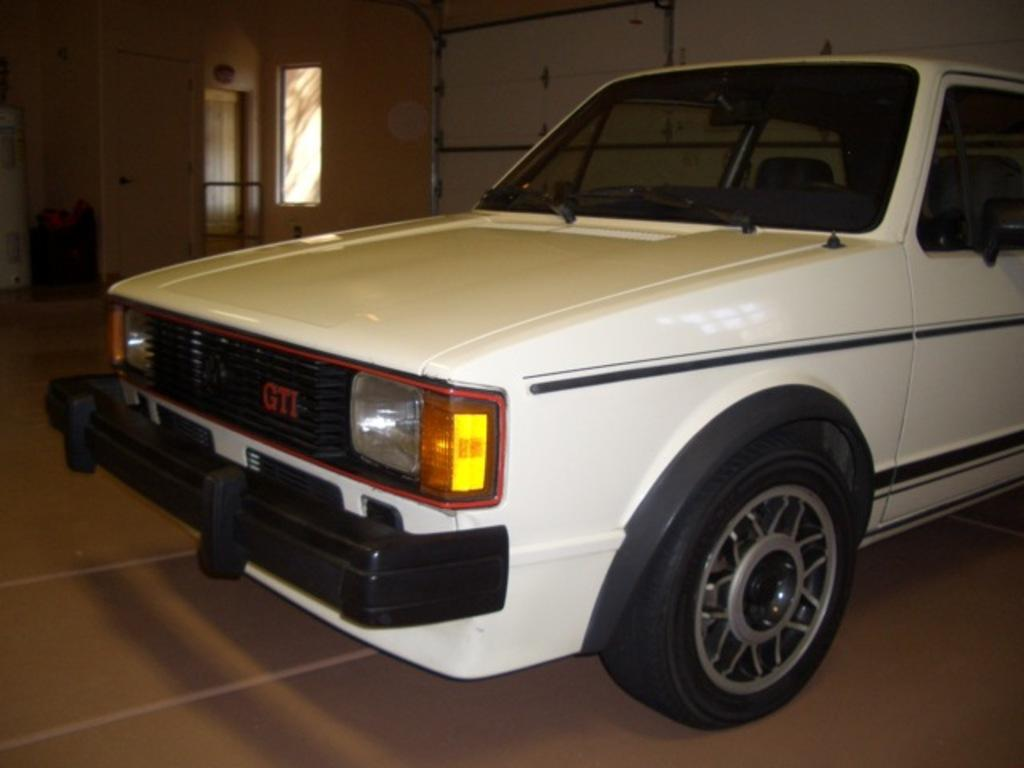What is the main subject in the image? There is a vehicle in the image. Where is the vehicle located in relation to other objects? The vehicle is beside a wall. What can be seen in the top left corner of the image? There is a window and a door in the top left corner of the image. Reasoning: Let's think step by step by step in order to produce the conversation. We start by identifying the main subject of the image, which is the vehicle. Next, we describe the vehicle's location in relation to other objects, such as the wall. Then, we observe the top left corner of the image, noting the presence of both a window and a door. Absurd Question/Answer: What type of cork can be seen supporting the vehicle in the image? There is no cork present in the image, nor is the vehicle being supported by any cork. 